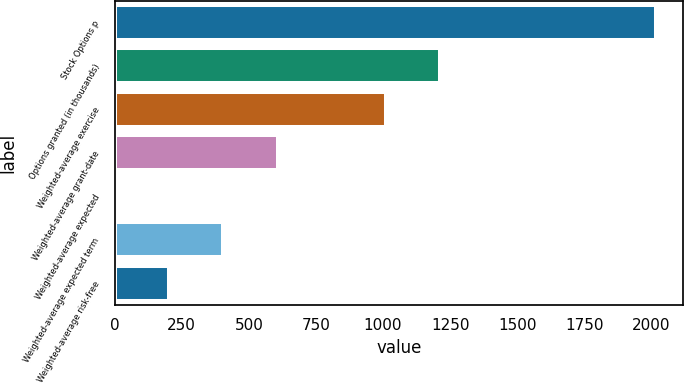Convert chart. <chart><loc_0><loc_0><loc_500><loc_500><bar_chart><fcel>Stock Options p<fcel>Options granted (in thousands)<fcel>Weighted-average exercise<fcel>Weighted-average grant-date<fcel>Weighted-average expected<fcel>Weighted-average expected term<fcel>Weighted-average risk-free<nl><fcel>2018<fcel>1211.64<fcel>1010.05<fcel>606.87<fcel>2.1<fcel>405.28<fcel>203.69<nl></chart> 